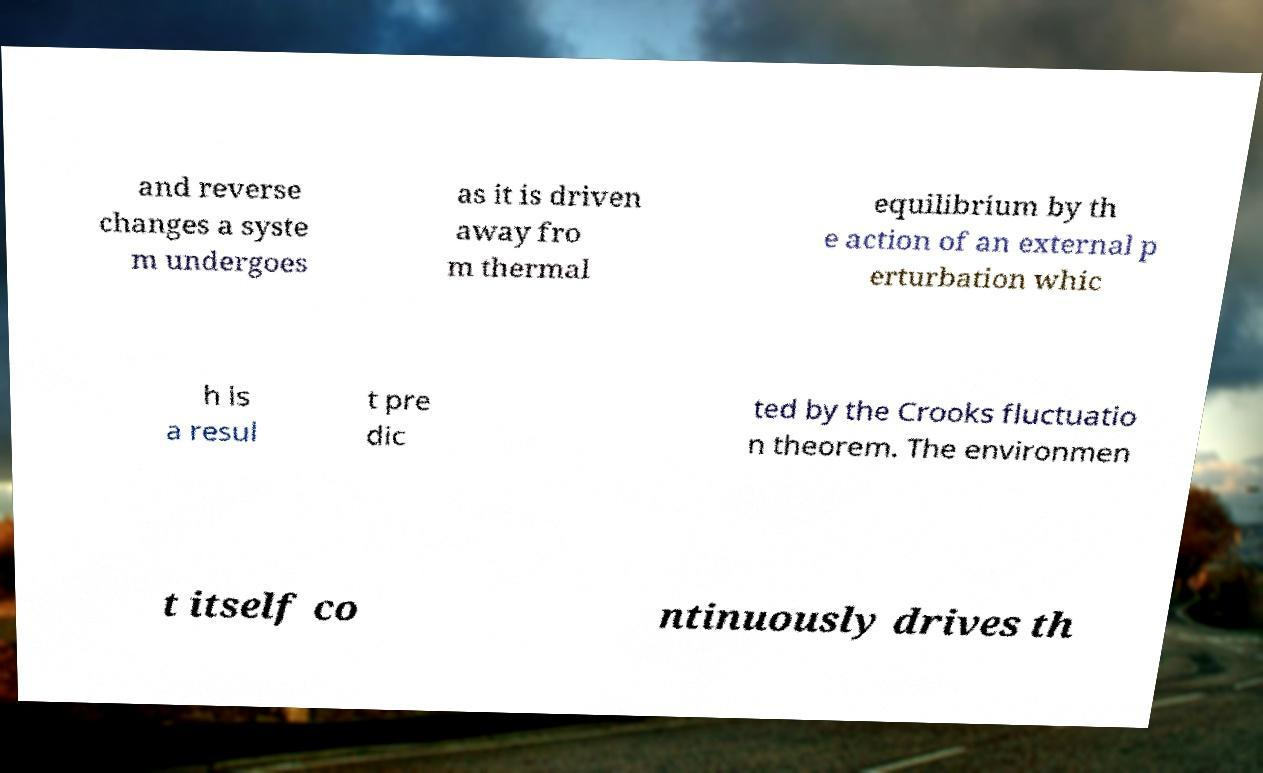There's text embedded in this image that I need extracted. Can you transcribe it verbatim? and reverse changes a syste m undergoes as it is driven away fro m thermal equilibrium by th e action of an external p erturbation whic h is a resul t pre dic ted by the Crooks fluctuatio n theorem. The environmen t itself co ntinuously drives th 